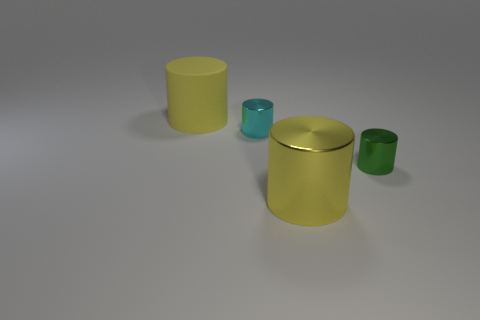What is the size of the cylinder that is to the right of the large object that is right of the matte cylinder?
Ensure brevity in your answer.  Small. What is the color of the big rubber cylinder?
Your answer should be very brief. Yellow. Are there any large shiny cylinders to the left of the cyan object?
Your response must be concise. No. Are there any large yellow objects made of the same material as the tiny cyan thing?
Your answer should be very brief. Yes. The thing that is the same color as the large metal cylinder is what size?
Keep it short and to the point. Large. What number of balls are matte things or metallic things?
Offer a terse response. 0. Is the number of yellow objects that are on the left side of the large metallic cylinder greater than the number of shiny cylinders on the left side of the small cyan shiny object?
Your answer should be compact. Yes. What number of big cylinders have the same color as the matte object?
Your answer should be very brief. 1. What is the size of the green object that is the same material as the cyan thing?
Make the answer very short. Small. What number of things are large yellow cylinders behind the tiny cyan object or red matte balls?
Provide a succinct answer. 1. 